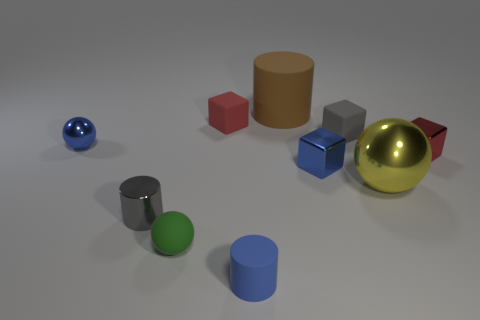Is there a blue rubber ball of the same size as the yellow thing?
Provide a short and direct response. No. Do the red block that is on the right side of the large matte cylinder and the green object have the same material?
Keep it short and to the point. No. Are there an equal number of small metallic objects that are on the left side of the yellow thing and tiny blue balls that are to the right of the large matte cylinder?
Ensure brevity in your answer.  No. There is a metallic thing that is left of the big sphere and behind the tiny blue metal cube; what is its shape?
Your response must be concise. Sphere. There is a matte sphere; what number of small shiny objects are to the right of it?
Offer a very short reply. 2. How many other objects are the same shape as the tiny gray rubber object?
Your answer should be compact. 3. Is the number of big cylinders less than the number of red balls?
Offer a terse response. No. There is a cylinder that is in front of the blue metal cube and right of the gray metallic cylinder; what is its size?
Your answer should be compact. Small. How big is the gray object in front of the blue metallic object to the left of the small gray metal thing to the left of the small green sphere?
Give a very brief answer. Small. The red matte block has what size?
Ensure brevity in your answer.  Small. 